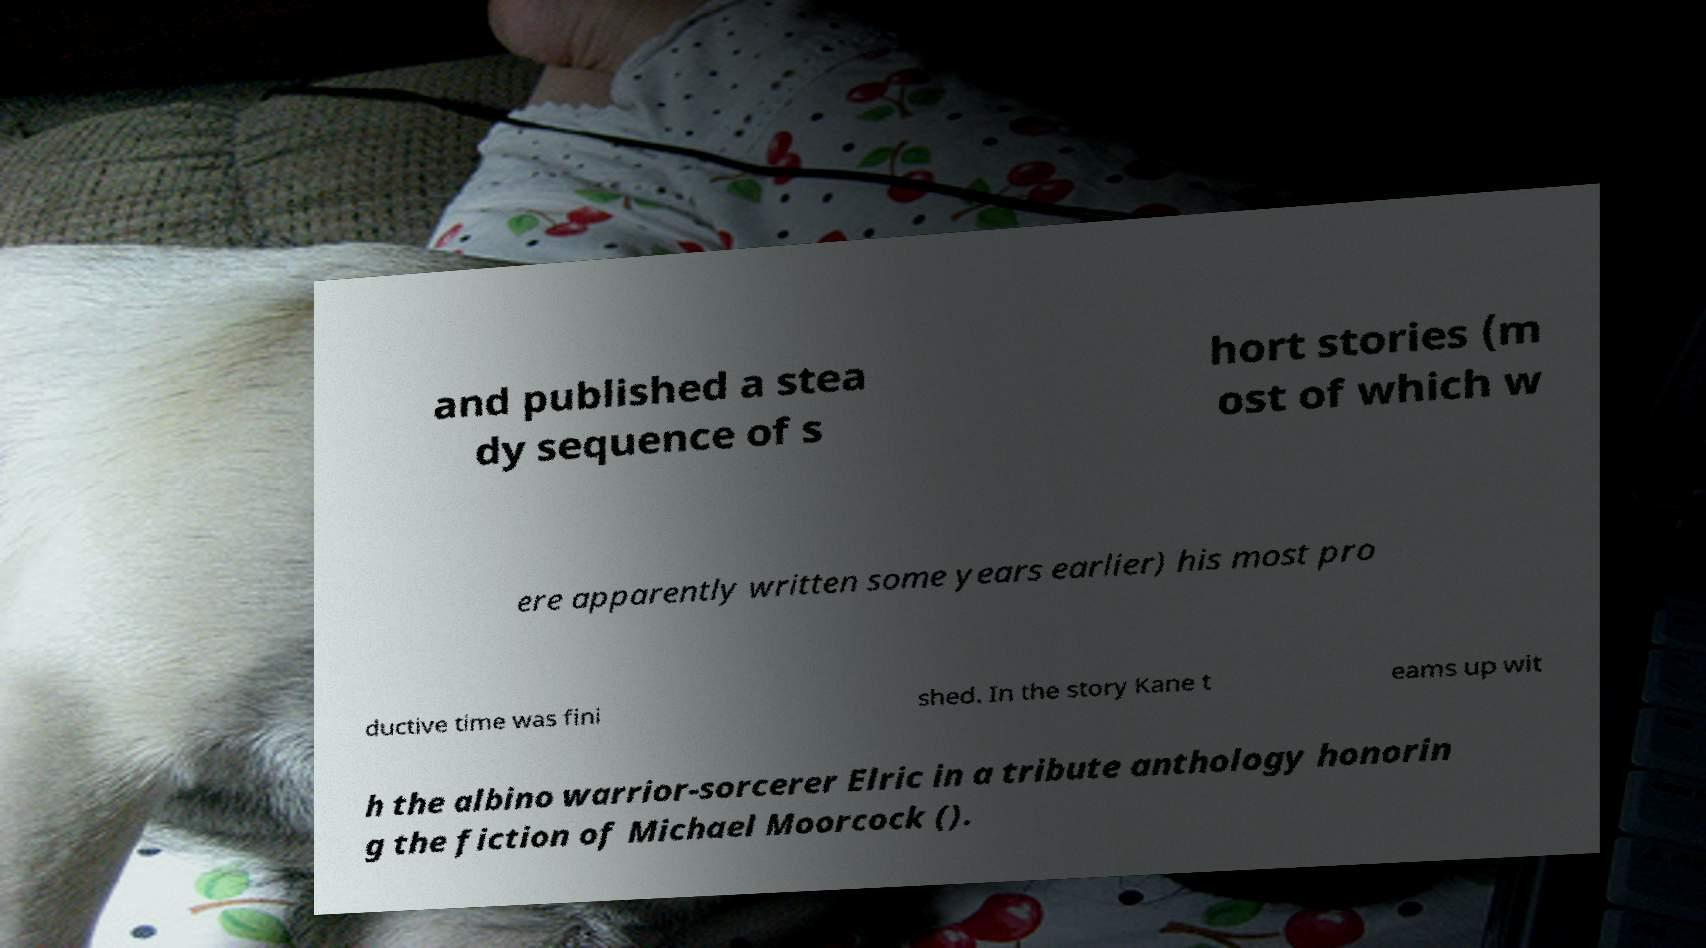Please read and relay the text visible in this image. What does it say? and published a stea dy sequence of s hort stories (m ost of which w ere apparently written some years earlier) his most pro ductive time was fini shed. In the story Kane t eams up wit h the albino warrior-sorcerer Elric in a tribute anthology honorin g the fiction of Michael Moorcock (). 